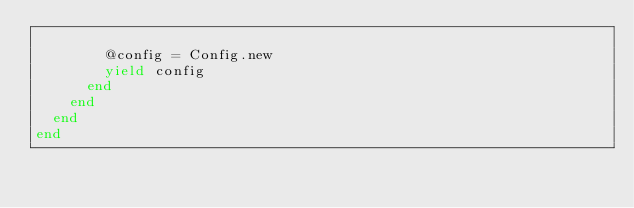Convert code to text. <code><loc_0><loc_0><loc_500><loc_500><_Ruby_>
        @config = Config.new
        yield config
      end
    end
  end
end
</code> 